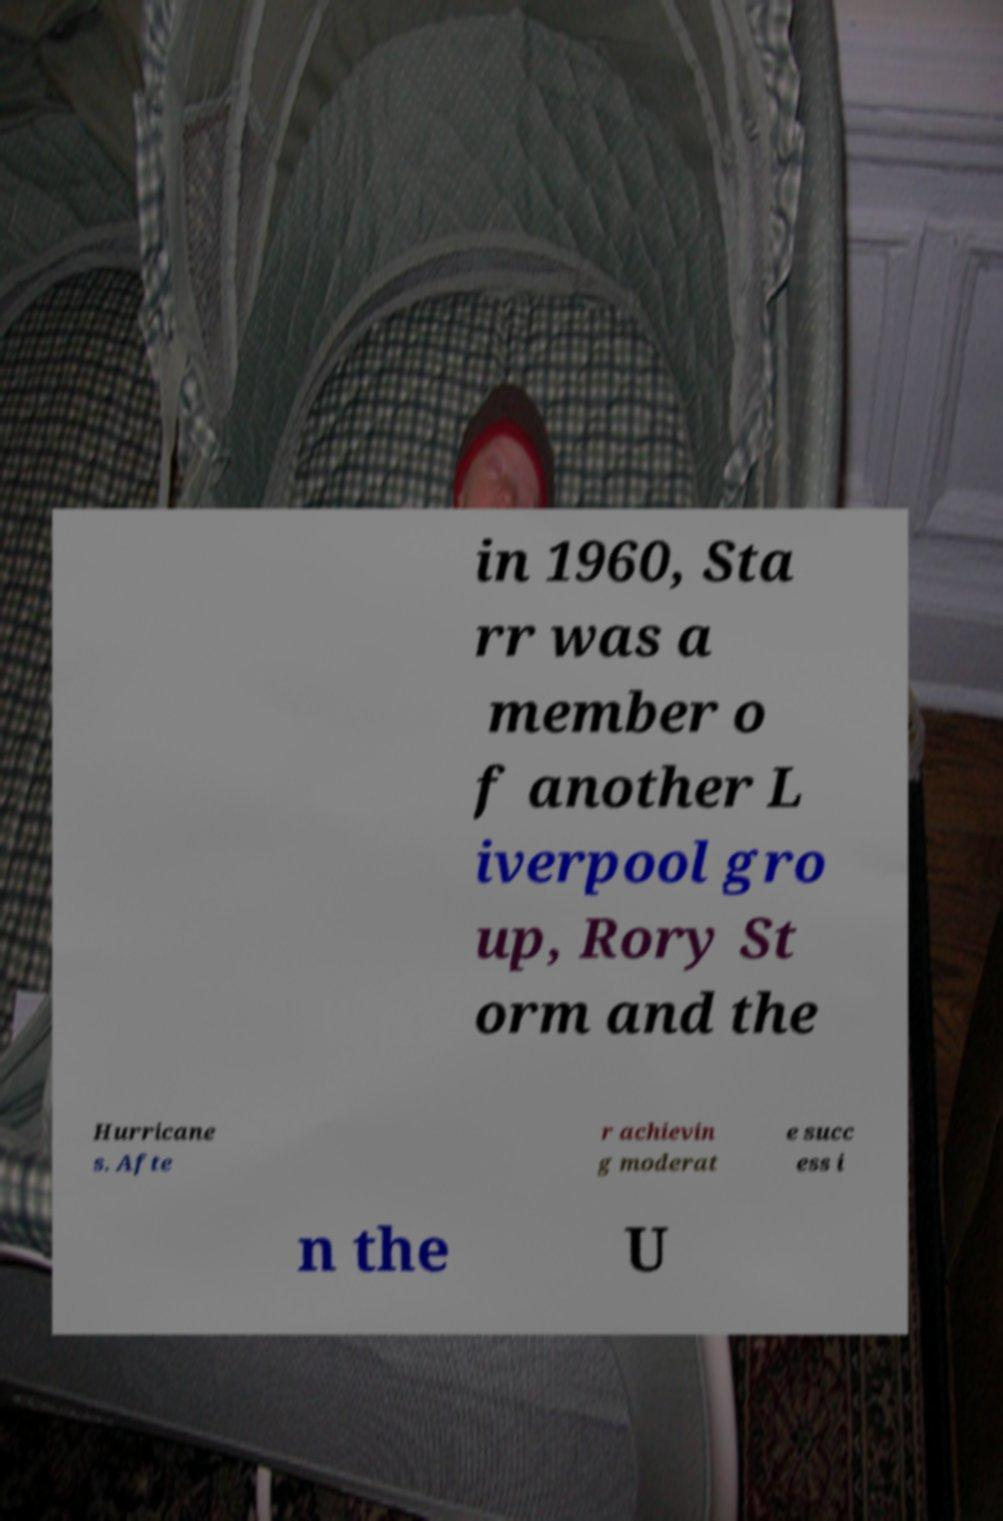Could you extract and type out the text from this image? in 1960, Sta rr was a member o f another L iverpool gro up, Rory St orm and the Hurricane s. Afte r achievin g moderat e succ ess i n the U 